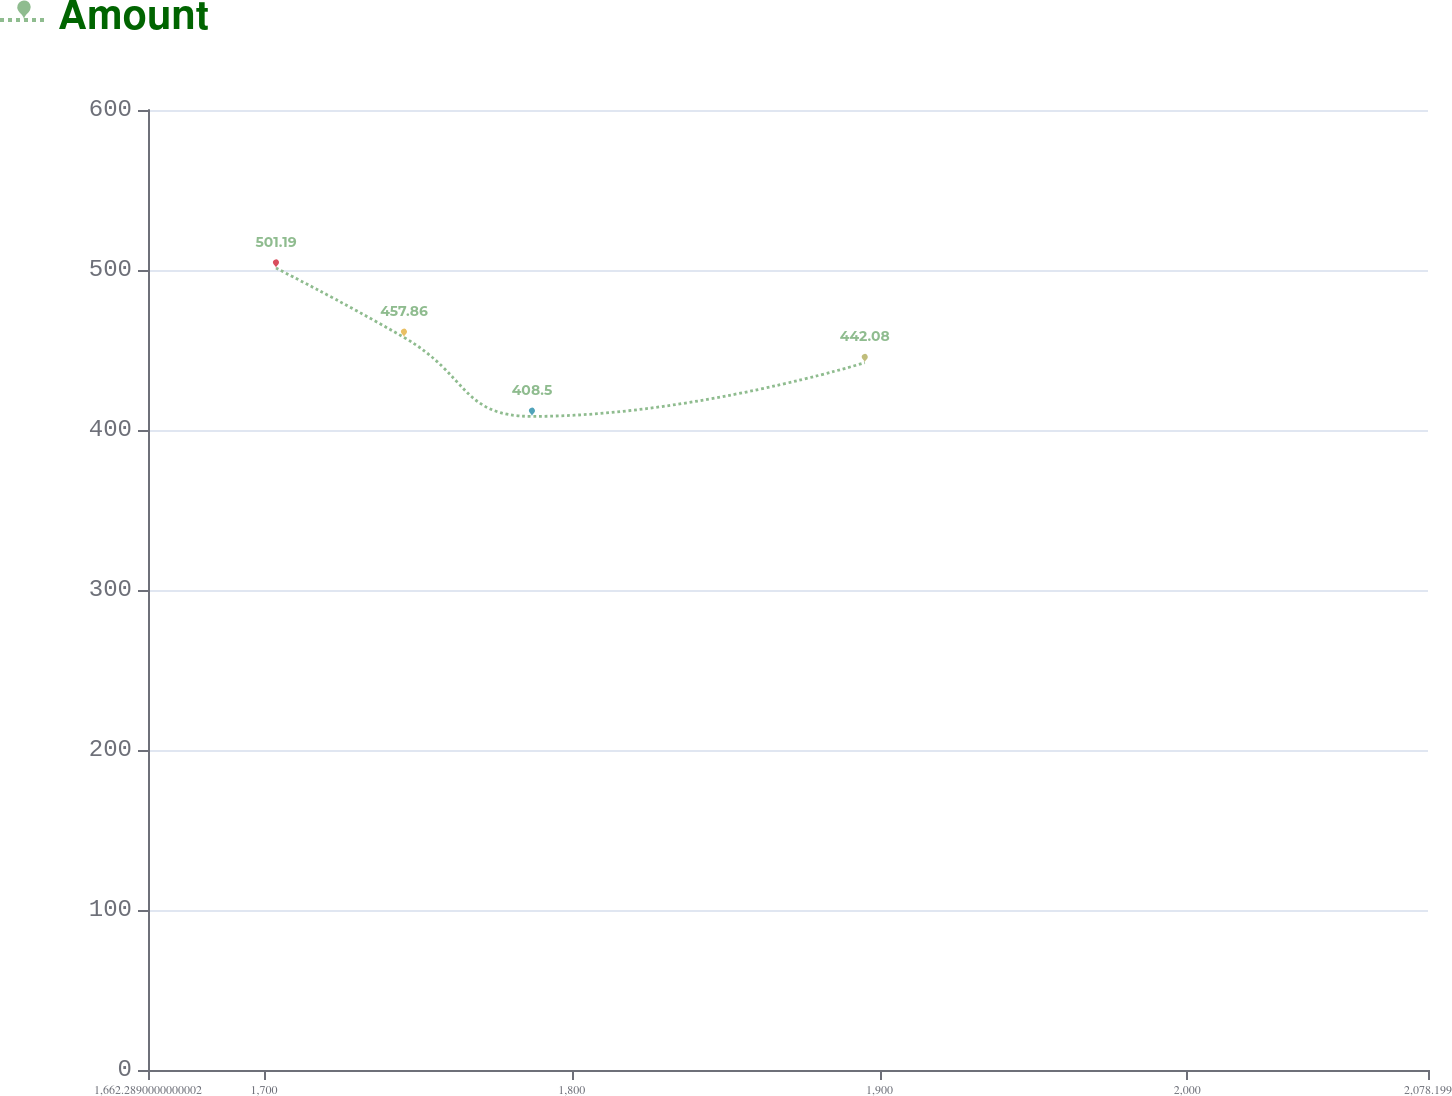Convert chart. <chart><loc_0><loc_0><loc_500><loc_500><line_chart><ecel><fcel>Amount<nl><fcel>1703.88<fcel>501.19<nl><fcel>1745.47<fcel>457.86<nl><fcel>1787.06<fcel>408.5<nl><fcel>1895.2<fcel>442.08<nl><fcel>2119.79<fcel>432.81<nl></chart> 